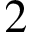<formula> <loc_0><loc_0><loc_500><loc_500>2</formula> 